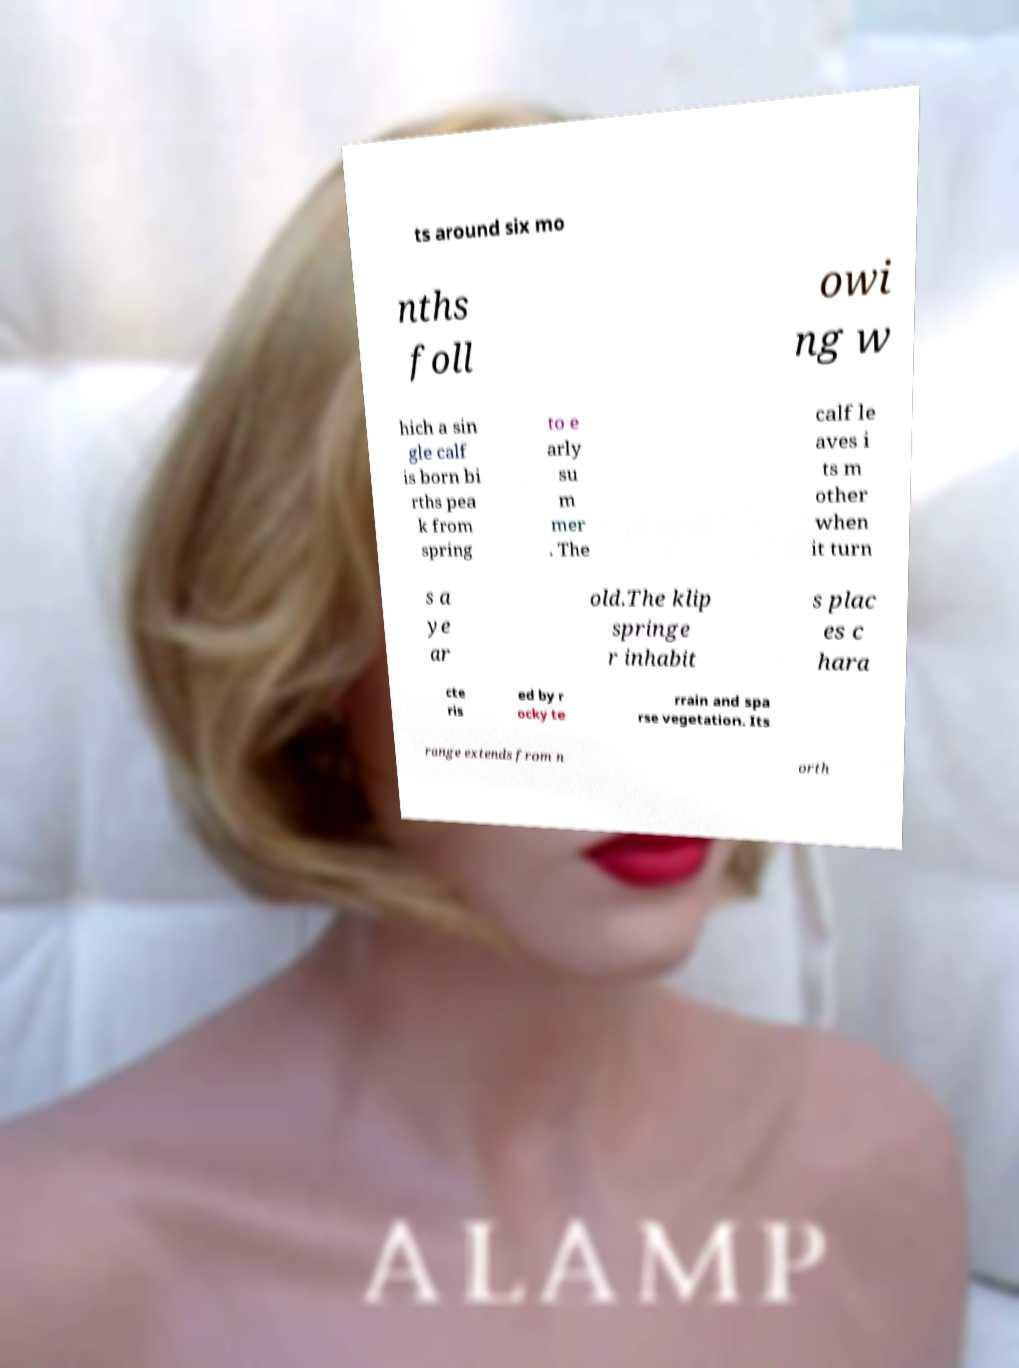Can you accurately transcribe the text from the provided image for me? ts around six mo nths foll owi ng w hich a sin gle calf is born bi rths pea k from spring to e arly su m mer . The calf le aves i ts m other when it turn s a ye ar old.The klip springe r inhabit s plac es c hara cte ris ed by r ocky te rrain and spa rse vegetation. Its range extends from n orth 